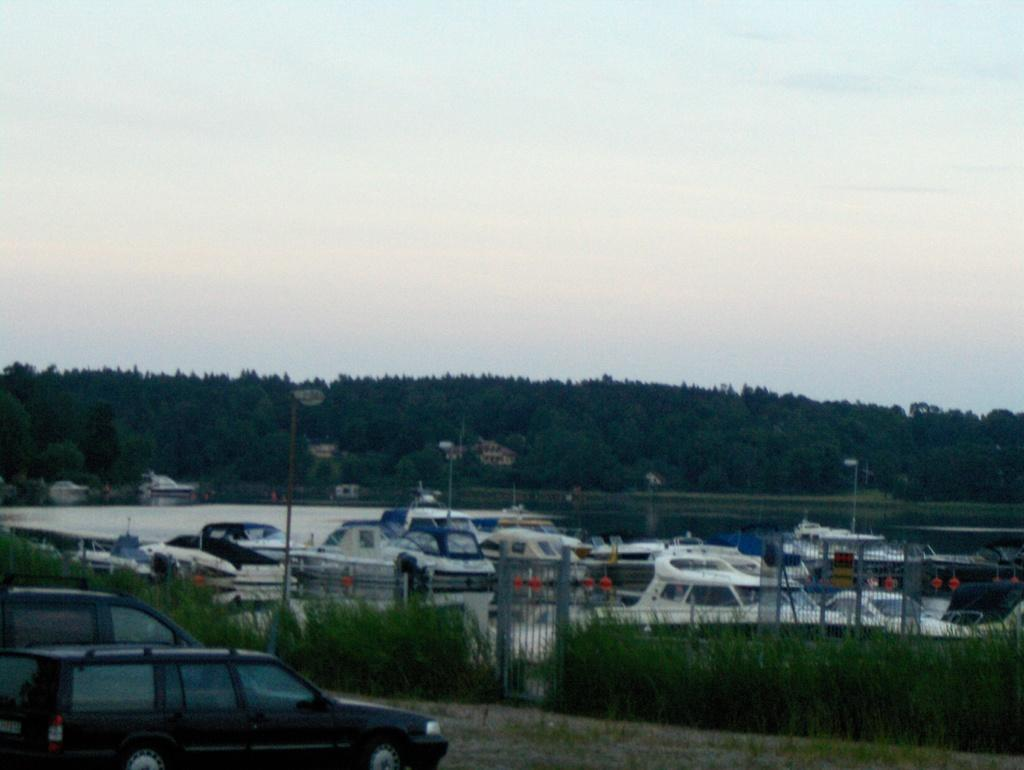What type of vehicles can be seen in the image? There are cars in the image. What type of barrier is present in the image? There is fencing in the image. Is there an entrance or exit in the image? Yes, there is a gate in the image. What can be seen in the background of the image? There are trees and light poles in the background of the image. What is visible at the top of the image? The sky is visible at the top of the image. Where is the clock located in the image? There is no clock present in the image. What type of seat can be seen in the image? There is no seat present in the image. 